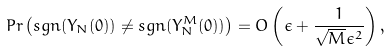<formula> <loc_0><loc_0><loc_500><loc_500>P r \left ( s g n ( Y _ { N } ( 0 ) ) \ne s g n ( Y _ { N } ^ { M } ( 0 ) ) \right ) = O \left ( \epsilon + \frac { 1 } { \sqrt { M } \epsilon ^ { 2 } } \right ) ,</formula> 